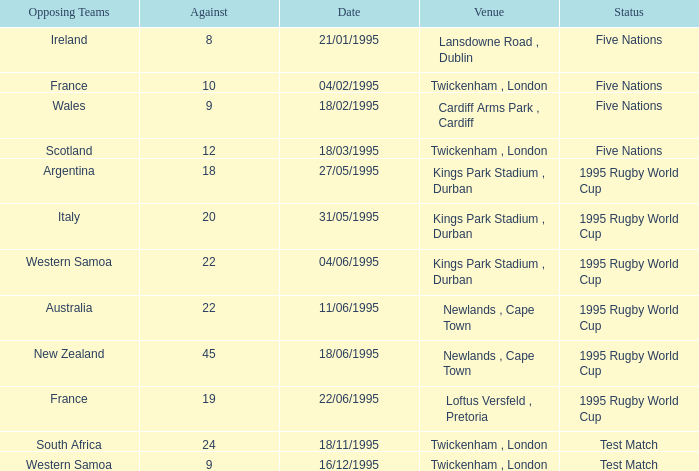What was the date of the status test match featuring an opposition team from south africa? 18/11/1995. 